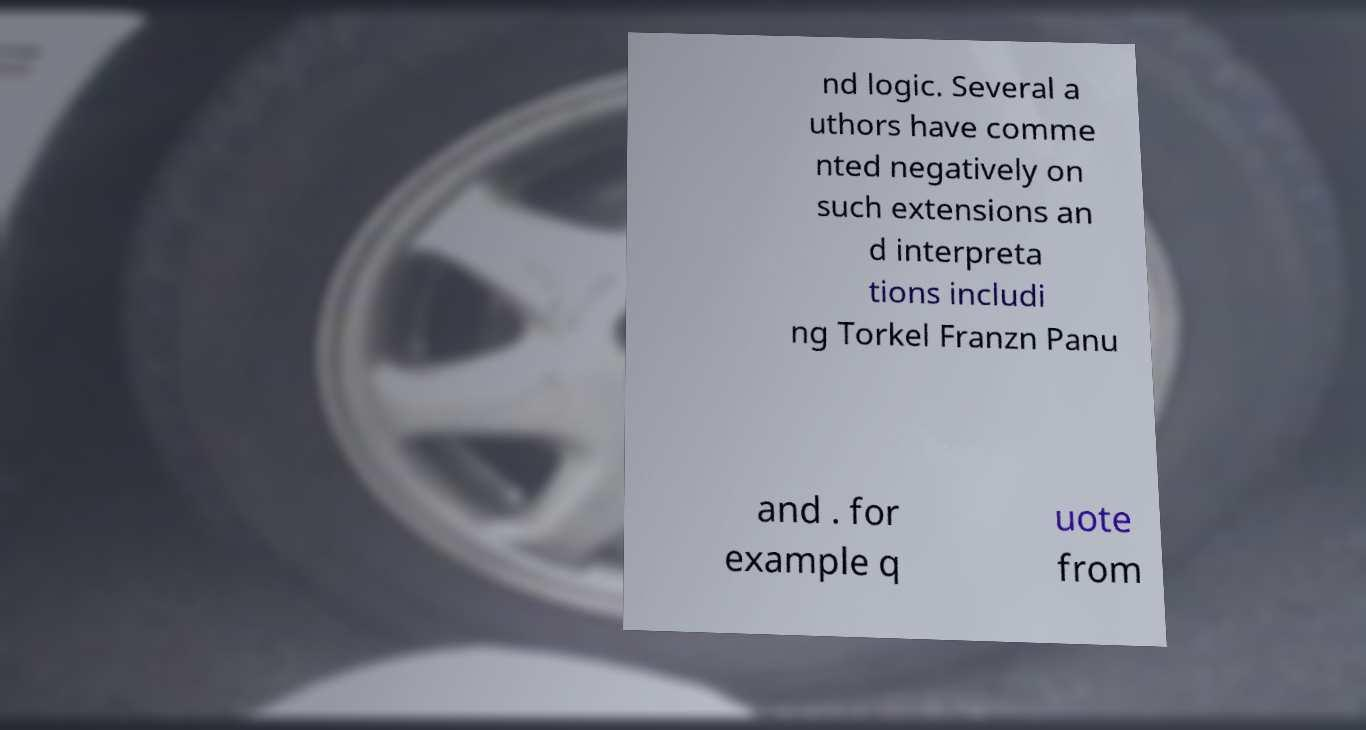There's text embedded in this image that I need extracted. Can you transcribe it verbatim? nd logic. Several a uthors have comme nted negatively on such extensions an d interpreta tions includi ng Torkel Franzn Panu and . for example q uote from 